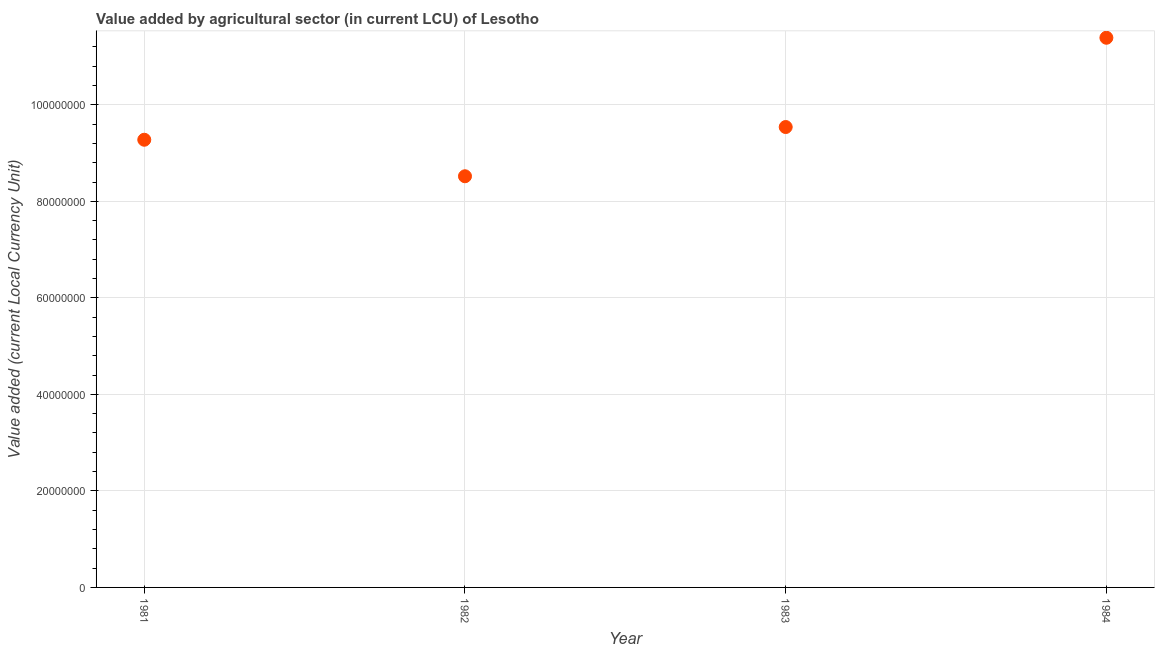What is the value added by agriculture sector in 1984?
Offer a terse response. 1.14e+08. Across all years, what is the maximum value added by agriculture sector?
Offer a very short reply. 1.14e+08. Across all years, what is the minimum value added by agriculture sector?
Your answer should be very brief. 8.52e+07. In which year was the value added by agriculture sector maximum?
Offer a very short reply. 1984. In which year was the value added by agriculture sector minimum?
Offer a terse response. 1982. What is the sum of the value added by agriculture sector?
Your answer should be very brief. 3.87e+08. What is the difference between the value added by agriculture sector in 1981 and 1984?
Provide a short and direct response. -2.11e+07. What is the average value added by agriculture sector per year?
Provide a short and direct response. 9.68e+07. What is the median value added by agriculture sector?
Your response must be concise. 9.41e+07. What is the ratio of the value added by agriculture sector in 1982 to that in 1984?
Provide a succinct answer. 0.75. What is the difference between the highest and the second highest value added by agriculture sector?
Provide a short and direct response. 1.85e+07. Is the sum of the value added by agriculture sector in 1981 and 1982 greater than the maximum value added by agriculture sector across all years?
Ensure brevity in your answer.  Yes. What is the difference between the highest and the lowest value added by agriculture sector?
Ensure brevity in your answer.  2.87e+07. How many dotlines are there?
Provide a short and direct response. 1. Does the graph contain any zero values?
Provide a succinct answer. No. Does the graph contain grids?
Ensure brevity in your answer.  Yes. What is the title of the graph?
Provide a short and direct response. Value added by agricultural sector (in current LCU) of Lesotho. What is the label or title of the X-axis?
Provide a succinct answer. Year. What is the label or title of the Y-axis?
Provide a succinct answer. Value added (current Local Currency Unit). What is the Value added (current Local Currency Unit) in 1981?
Keep it short and to the point. 9.28e+07. What is the Value added (current Local Currency Unit) in 1982?
Ensure brevity in your answer.  8.52e+07. What is the Value added (current Local Currency Unit) in 1983?
Keep it short and to the point. 9.54e+07. What is the Value added (current Local Currency Unit) in 1984?
Your response must be concise. 1.14e+08. What is the difference between the Value added (current Local Currency Unit) in 1981 and 1982?
Your answer should be very brief. 7.56e+06. What is the difference between the Value added (current Local Currency Unit) in 1981 and 1983?
Make the answer very short. -2.64e+06. What is the difference between the Value added (current Local Currency Unit) in 1981 and 1984?
Offer a very short reply. -2.11e+07. What is the difference between the Value added (current Local Currency Unit) in 1982 and 1983?
Provide a succinct answer. -1.02e+07. What is the difference between the Value added (current Local Currency Unit) in 1982 and 1984?
Keep it short and to the point. -2.87e+07. What is the difference between the Value added (current Local Currency Unit) in 1983 and 1984?
Offer a terse response. -1.85e+07. What is the ratio of the Value added (current Local Currency Unit) in 1981 to that in 1982?
Ensure brevity in your answer.  1.09. What is the ratio of the Value added (current Local Currency Unit) in 1981 to that in 1983?
Your response must be concise. 0.97. What is the ratio of the Value added (current Local Currency Unit) in 1981 to that in 1984?
Offer a very short reply. 0.81. What is the ratio of the Value added (current Local Currency Unit) in 1982 to that in 1983?
Provide a short and direct response. 0.89. What is the ratio of the Value added (current Local Currency Unit) in 1982 to that in 1984?
Keep it short and to the point. 0.75. What is the ratio of the Value added (current Local Currency Unit) in 1983 to that in 1984?
Keep it short and to the point. 0.84. 